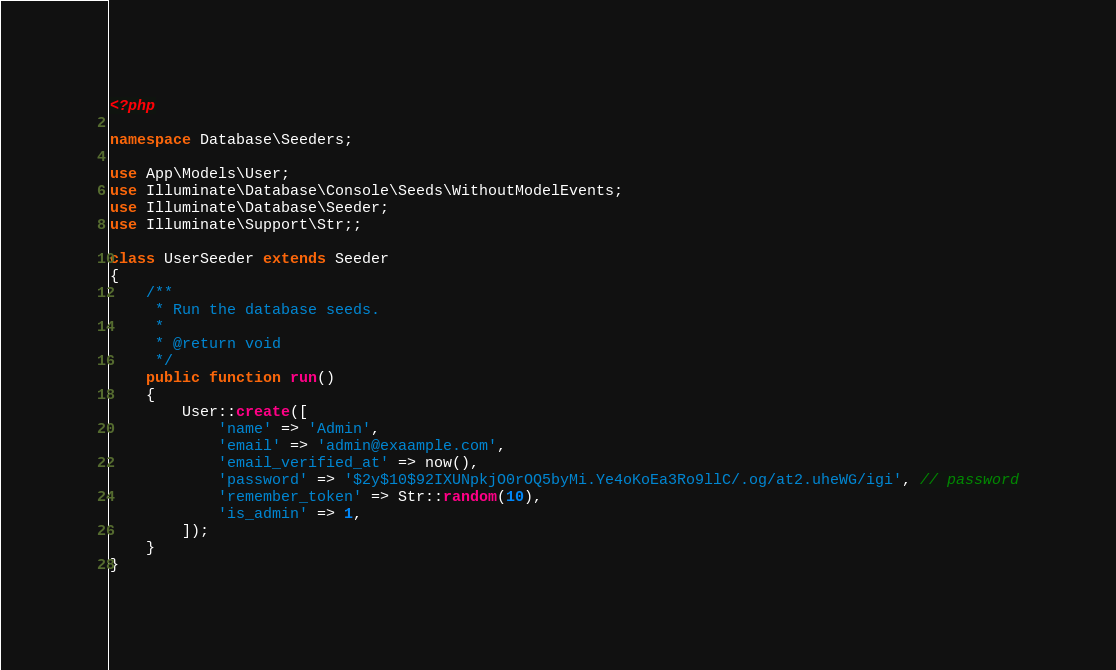Convert code to text. <code><loc_0><loc_0><loc_500><loc_500><_PHP_><?php

namespace Database\Seeders;

use App\Models\User;
use Illuminate\Database\Console\Seeds\WithoutModelEvents;
use Illuminate\Database\Seeder;
use Illuminate\Support\Str;;

class UserSeeder extends Seeder
{
    /**
     * Run the database seeds.
     *
     * @return void
     */
    public function run()
    {
        User::create([
            'name' => 'Admin',
            'email' => 'admin@exaample.com',
            'email_verified_at' => now(),
            'password' => '$2y$10$92IXUNpkjO0rOQ5byMi.Ye4oKoEa3Ro9llC/.og/at2.uheWG/igi', // password
            'remember_token' => Str::random(10),
            'is_admin' => 1,
        ]);
    }
}
</code> 